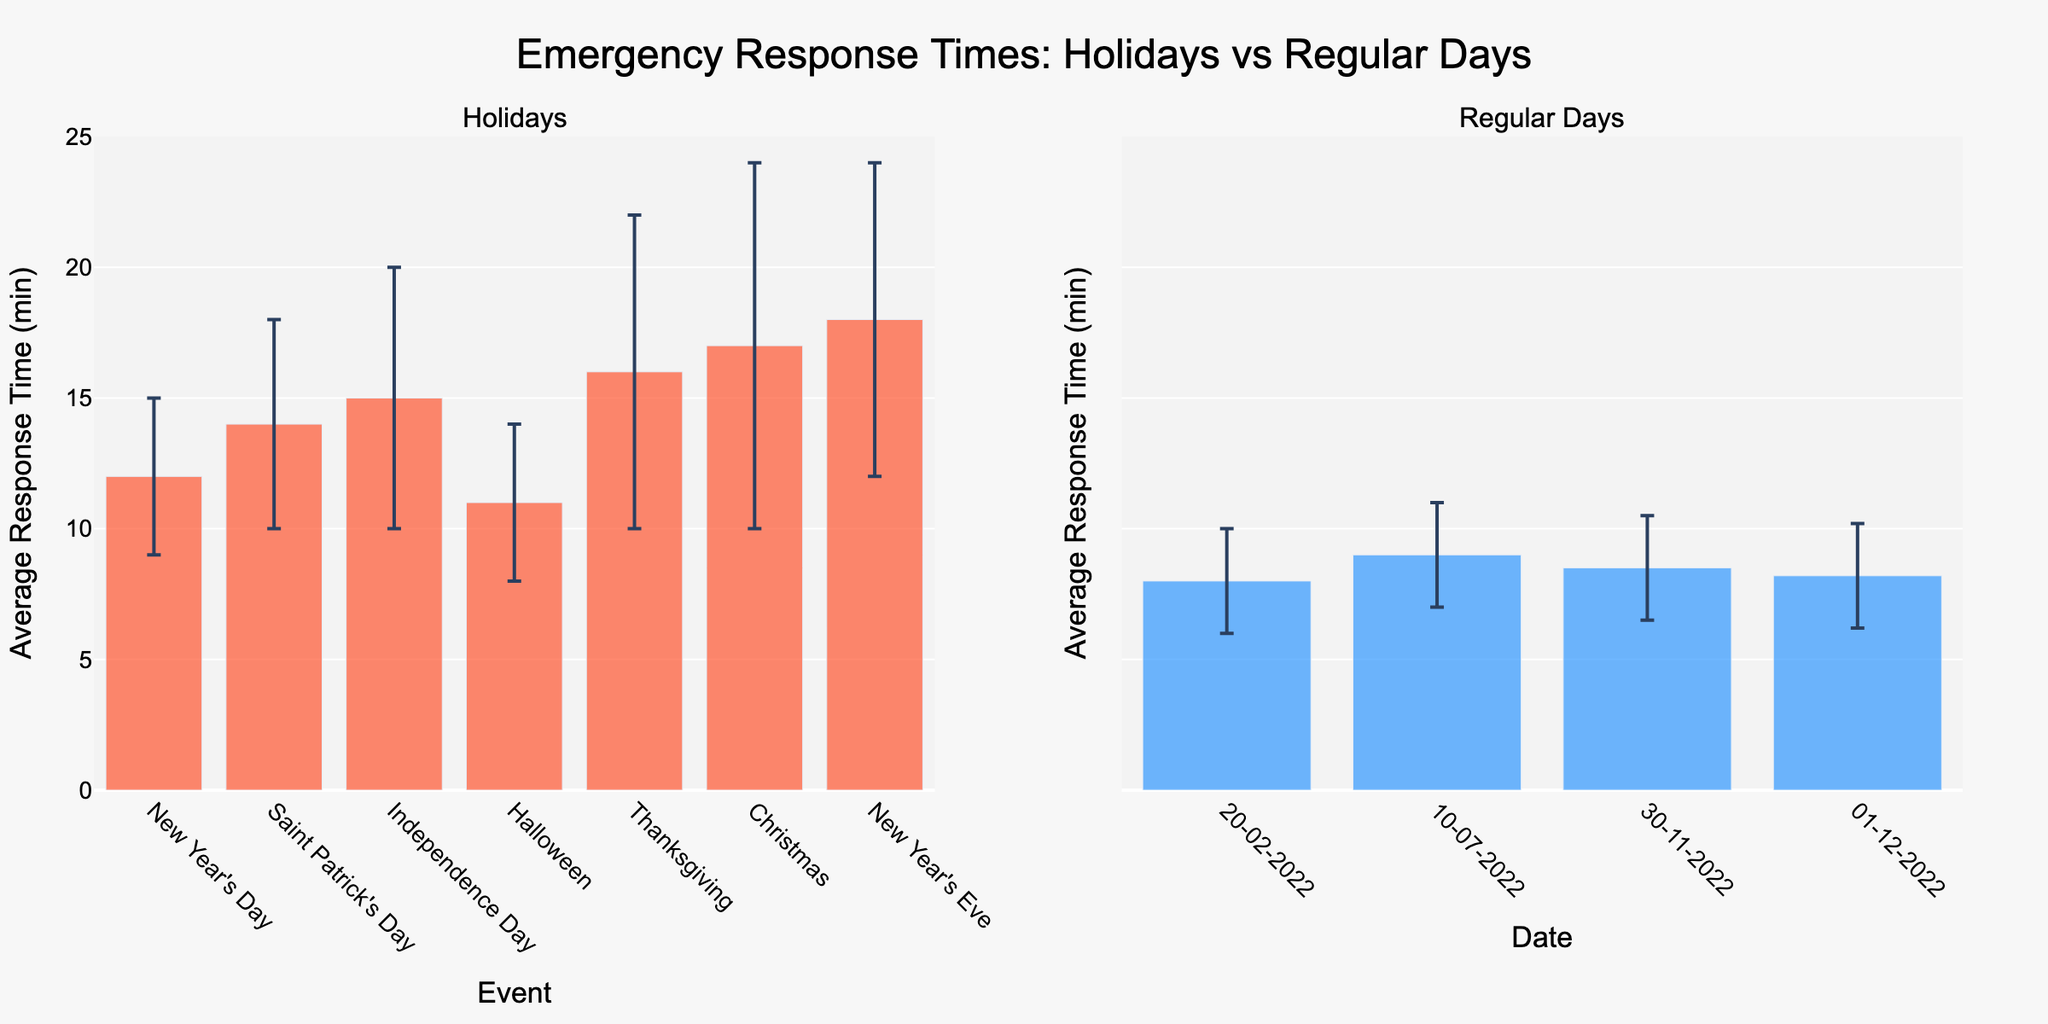What's the title of the figure? The title of the figure is displayed prominently at the top, indicating the overall subject of the visualization. It reads "Emergency Response Times: Holidays vs Regular Days."
Answer: Emergency Response Times: Holidays vs Regular Days What is the average response time for Independence Day? We locate the bar labeled "Independence Day" in the Holidays section of the figure. The figure shows that the bar's height is 15 minutes.
Answer: 15 minutes Which event has the highest average response time among holidays? By examining the heights of the bars in the Holidays subplot, we see that the bar for "New Year's Eve" is the tallest.
Answer: New Year's Eve What is the average response time for regular days not during holidays? We examine the bars in the Regular Days subplot and note the average response times: 8 minutes, 9 minutes, 8.5 minutes, and 8.2 minutes. We then average these values: (8 + 9 + 8.5 + 8.2) / 4 = 8.425 minutes.
Answer: 8.425 minutes How does the response time on Independence Day compare to that on Christmas? By observing the bars for "Independence Day" and "Christmas" in the Holidays subplot, we see that Independence Day has a response time of 15 minutes, while Christmas has 17 minutes.
Answer: Independence Day is 2 minutes lower What is the range of response times for regular days? We look at the minimum and maximum heights of the bars in the Regular Days subplot: minimum is 8 minutes on multiple dates, and the maximum is 9 minutes on July 10. The range is the difference, 9 - 8 = 1 minute.
Answer: 1 minute Which holiday event shows the greatest uncertainty in response time? The uncertainty or variability in response time can be assessed by the length of the error bars. "Christmas" shows the longest error bars in the Holidays subplot, indicating the greatest uncertainty.
Answer: Christmas Is there a significant difference in response time variances between holidays and regular days? We compare the lengths of the error bars in both subplots. Holidays generally display longer error bars than regular days, indicating greater response time variances during holidays.
Answer: Yes, holidays show greater variances What is the total average response time for all holiday events combined? Sum the average response times for all holiday events and divide by the number of events: (12 + 14 + 15 + 11 + 16 + 17 + 18) / 7 = 14.71 minutes.
Answer: 14.71 minutes 